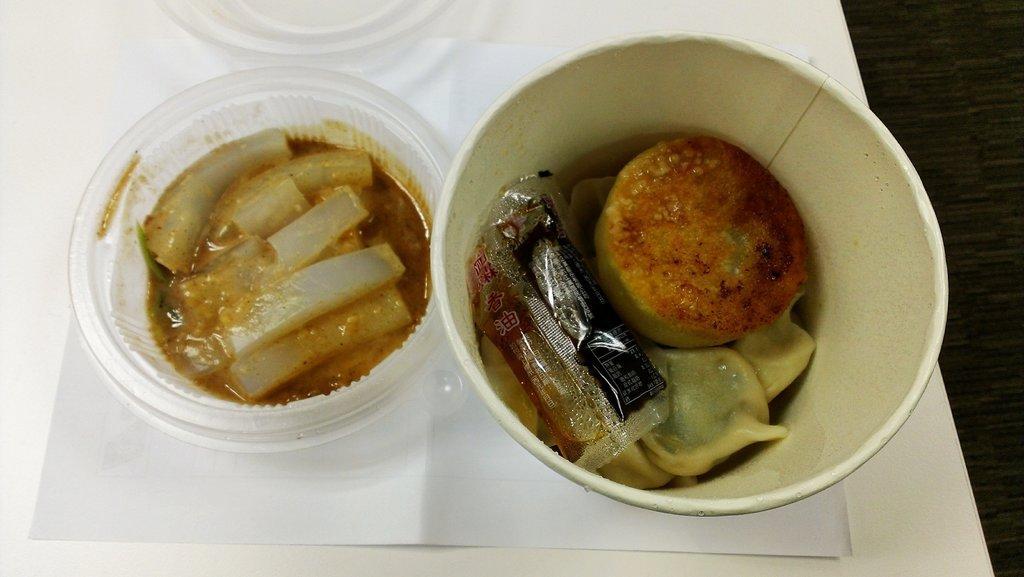Can you describe this image briefly? This image is taken indoors. On the right side of the image there is a table with a tray on it. In the middle of the image there are two bowls with food items on the tray. 